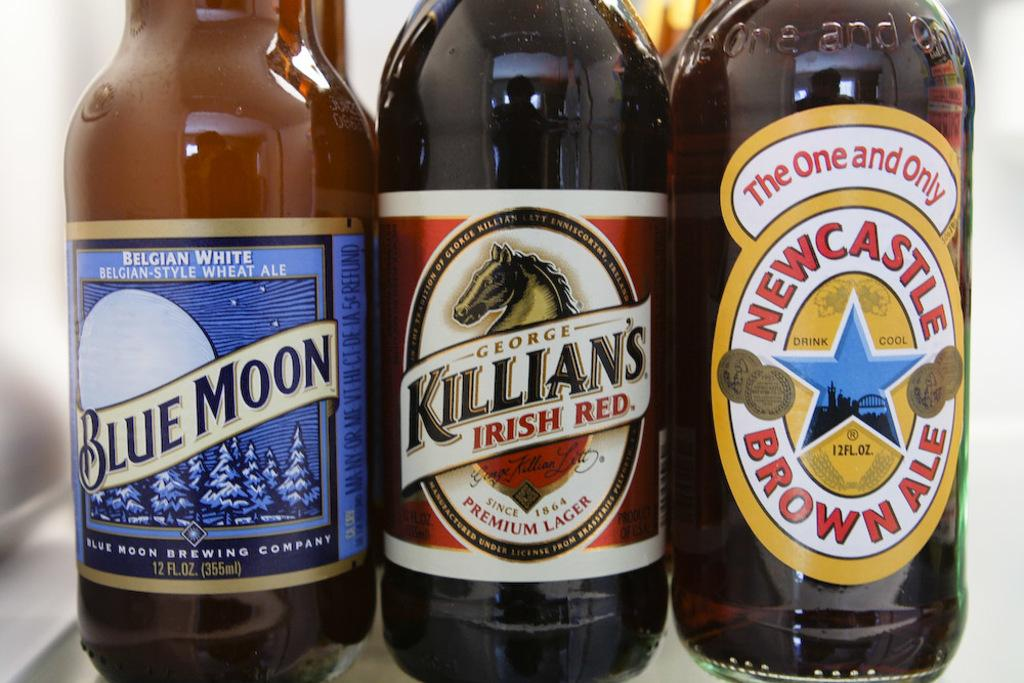<image>
Render a clear and concise summary of the photo. Three brown beer bottles, each with a different label displaying logos and either "Blue Moon", "Killian's Irish Red" or "Newcastle Brown Ale" 